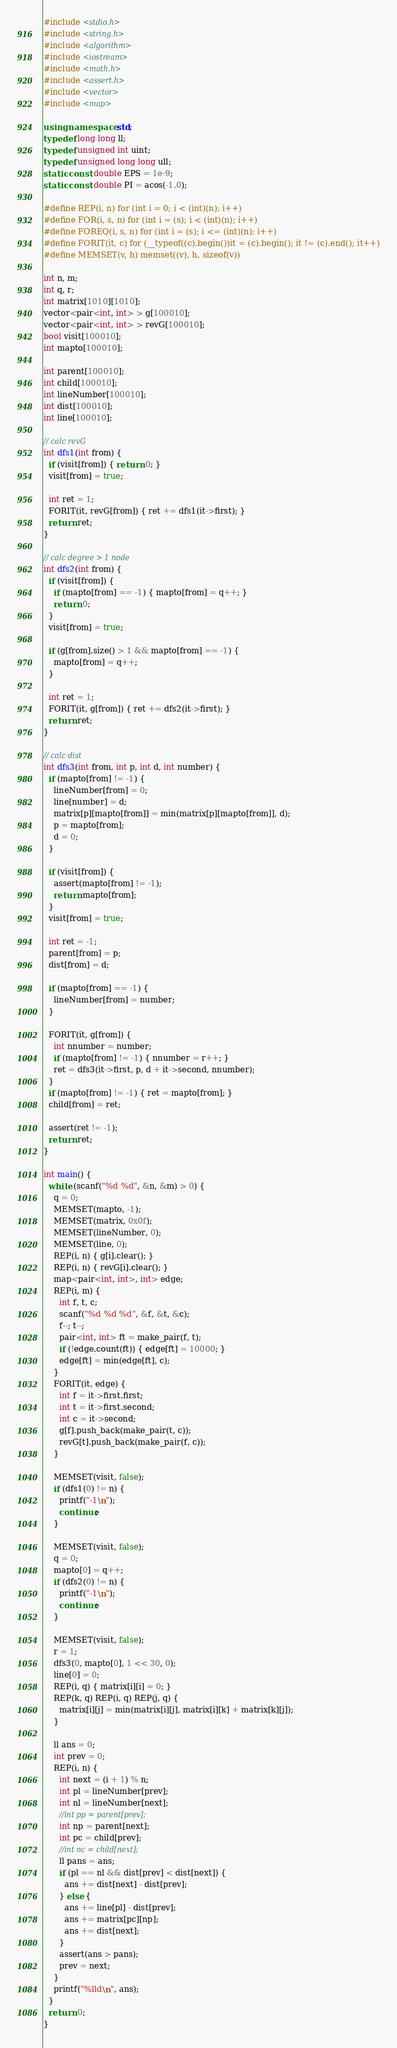<code> <loc_0><loc_0><loc_500><loc_500><_C++_>#include <stdio.h>
#include <string.h>
#include <algorithm>
#include <iostream>
#include <math.h>
#include <assert.h>
#include <vector>
#include <map>

using namespace std;
typedef long long ll;
typedef unsigned int uint;
typedef unsigned long long ull;
static const double EPS = 1e-9;
static const double PI = acos(-1.0);

#define REP(i, n) for (int i = 0; i < (int)(n); i++)
#define FOR(i, s, n) for (int i = (s); i < (int)(n); i++)
#define FOREQ(i, s, n) for (int i = (s); i <= (int)(n); i++)
#define FORIT(it, c) for (__typeof((c).begin())it = (c).begin(); it != (c).end(); it++)
#define MEMSET(v, h) memset((v), h, sizeof(v))

int n, m;
int q, r;
int matrix[1010][1010];
vector<pair<int, int> > g[100010];
vector<pair<int, int> > revG[100010];
bool visit[100010];
int mapto[100010];

int parent[100010];
int child[100010];
int lineNumber[100010];
int dist[100010];
int line[100010];

// calc revG
int dfs1(int from) {
  if (visit[from]) { return 0; }
  visit[from] = true;

  int ret = 1;
  FORIT(it, revG[from]) { ret += dfs1(it->first); }
  return ret;
}

// calc degree > 1 node
int dfs2(int from) {
  if (visit[from]) {
    if (mapto[from] == -1) { mapto[from] = q++; }
    return 0;
  }
  visit[from] = true;

  if (g[from].size() > 1 && mapto[from] == -1) {
    mapto[from] = q++;
  }

  int ret = 1;
  FORIT(it, g[from]) { ret += dfs2(it->first); }
  return ret;
}

// calc dist
int dfs3(int from, int p, int d, int number) {
  if (mapto[from] != -1) {
    lineNumber[from] = 0;
    line[number] = d;
    matrix[p][mapto[from]] = min(matrix[p][mapto[from]], d);
    p = mapto[from];
    d = 0;
  }

  if (visit[from]) {
    assert(mapto[from] != -1);
    return mapto[from];
  }
  visit[from] = true;

  int ret = -1;
  parent[from] = p;
  dist[from] = d;

  if (mapto[from] == -1) {
    lineNumber[from] = number;
  }

  FORIT(it, g[from]) {
    int nnumber = number;
    if (mapto[from] != -1) { nnumber = r++; }
    ret = dfs3(it->first, p, d + it->second, nnumber);
  }
  if (mapto[from] != -1) { ret = mapto[from]; }
  child[from] = ret;

  assert(ret != -1);
  return ret;
}

int main() {
  while (scanf("%d %d", &n, &m) > 0) {
    q = 0;
    MEMSET(mapto, -1);
    MEMSET(matrix, 0x0f);
    MEMSET(lineNumber, 0);
    MEMSET(line, 0);
    REP(i, n) { g[i].clear(); }
    REP(i, n) { revG[i].clear(); }
    map<pair<int, int>, int> edge;
    REP(i, m) {
      int f, t, c;
      scanf("%d %d %d", &f, &t, &c);
      f--; t--;
      pair<int, int> ft = make_pair(f, t);
      if (!edge.count(ft)) { edge[ft] = 10000; }
      edge[ft] = min(edge[ft], c);
    }
    FORIT(it, edge) {
      int f = it->first.first;
      int t = it->first.second;
      int c = it->second;
      g[f].push_back(make_pair(t, c));
      revG[t].push_back(make_pair(f, c));
    }

    MEMSET(visit, false);
    if (dfs1(0) != n) {
      printf("-1\n");
      continue;
    }

    MEMSET(visit, false);
    q = 0;
    mapto[0] = q++;
    if (dfs2(0) != n) {
      printf("-1\n");
      continue;
    }

    MEMSET(visit, false);
    r = 1;
    dfs3(0, mapto[0], 1 << 30, 0);
    line[0] = 0;
    REP(i, q) { matrix[i][i] = 0; }
    REP(k, q) REP(i, q) REP(j, q) {
      matrix[i][j] = min(matrix[i][j], matrix[i][k] + matrix[k][j]);
    }

    ll ans = 0;
    int prev = 0;
    REP(i, n) {
      int next = (i + 1) % n;
      int pl = lineNumber[prev];
      int nl = lineNumber[next];
      //int pp = parent[prev];
      int np = parent[next];
      int pc = child[prev];
      //int nc = child[next];
      ll pans = ans;
      if (pl == nl && dist[prev] < dist[next]) {
        ans += dist[next] - dist[prev];
      } else {
        ans += line[pl] - dist[prev];
        ans += matrix[pc][np];
        ans += dist[next];
      }
      assert(ans > pans);
      prev = next;
    }
    printf("%lld\n", ans);
  }
  return 0;
}</code> 